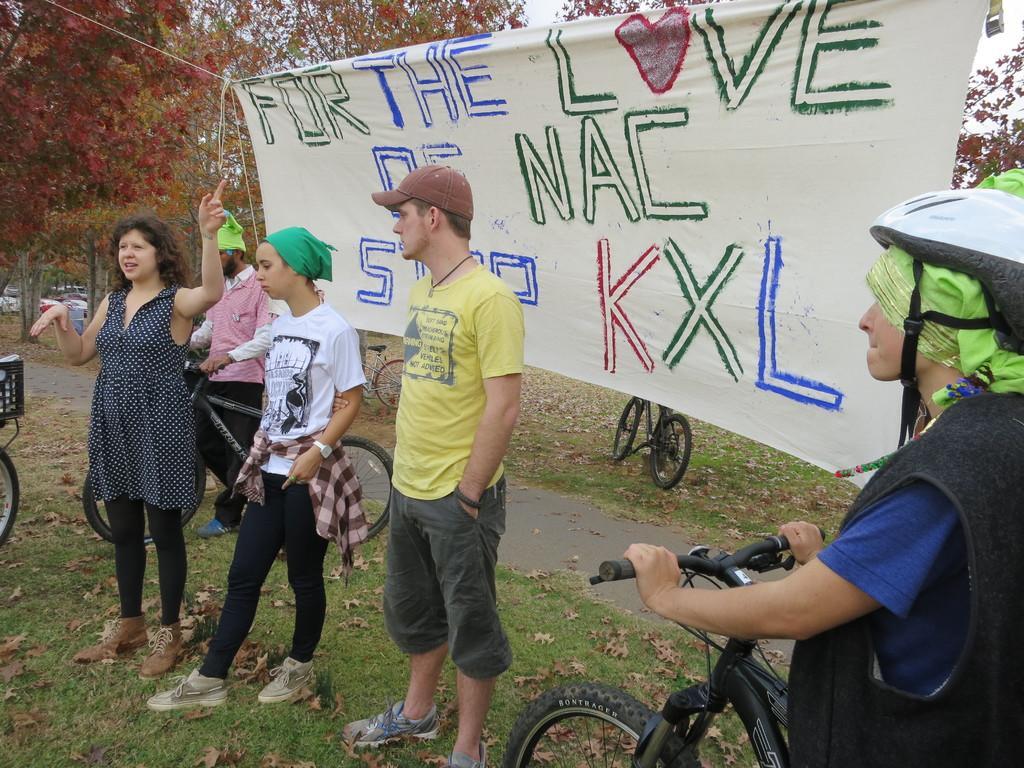In one or two sentences, can you explain what this image depicts? In this picture i could see some persons standing and walking with the bicycles in the park holding a banner. In the background i could see some trees. 